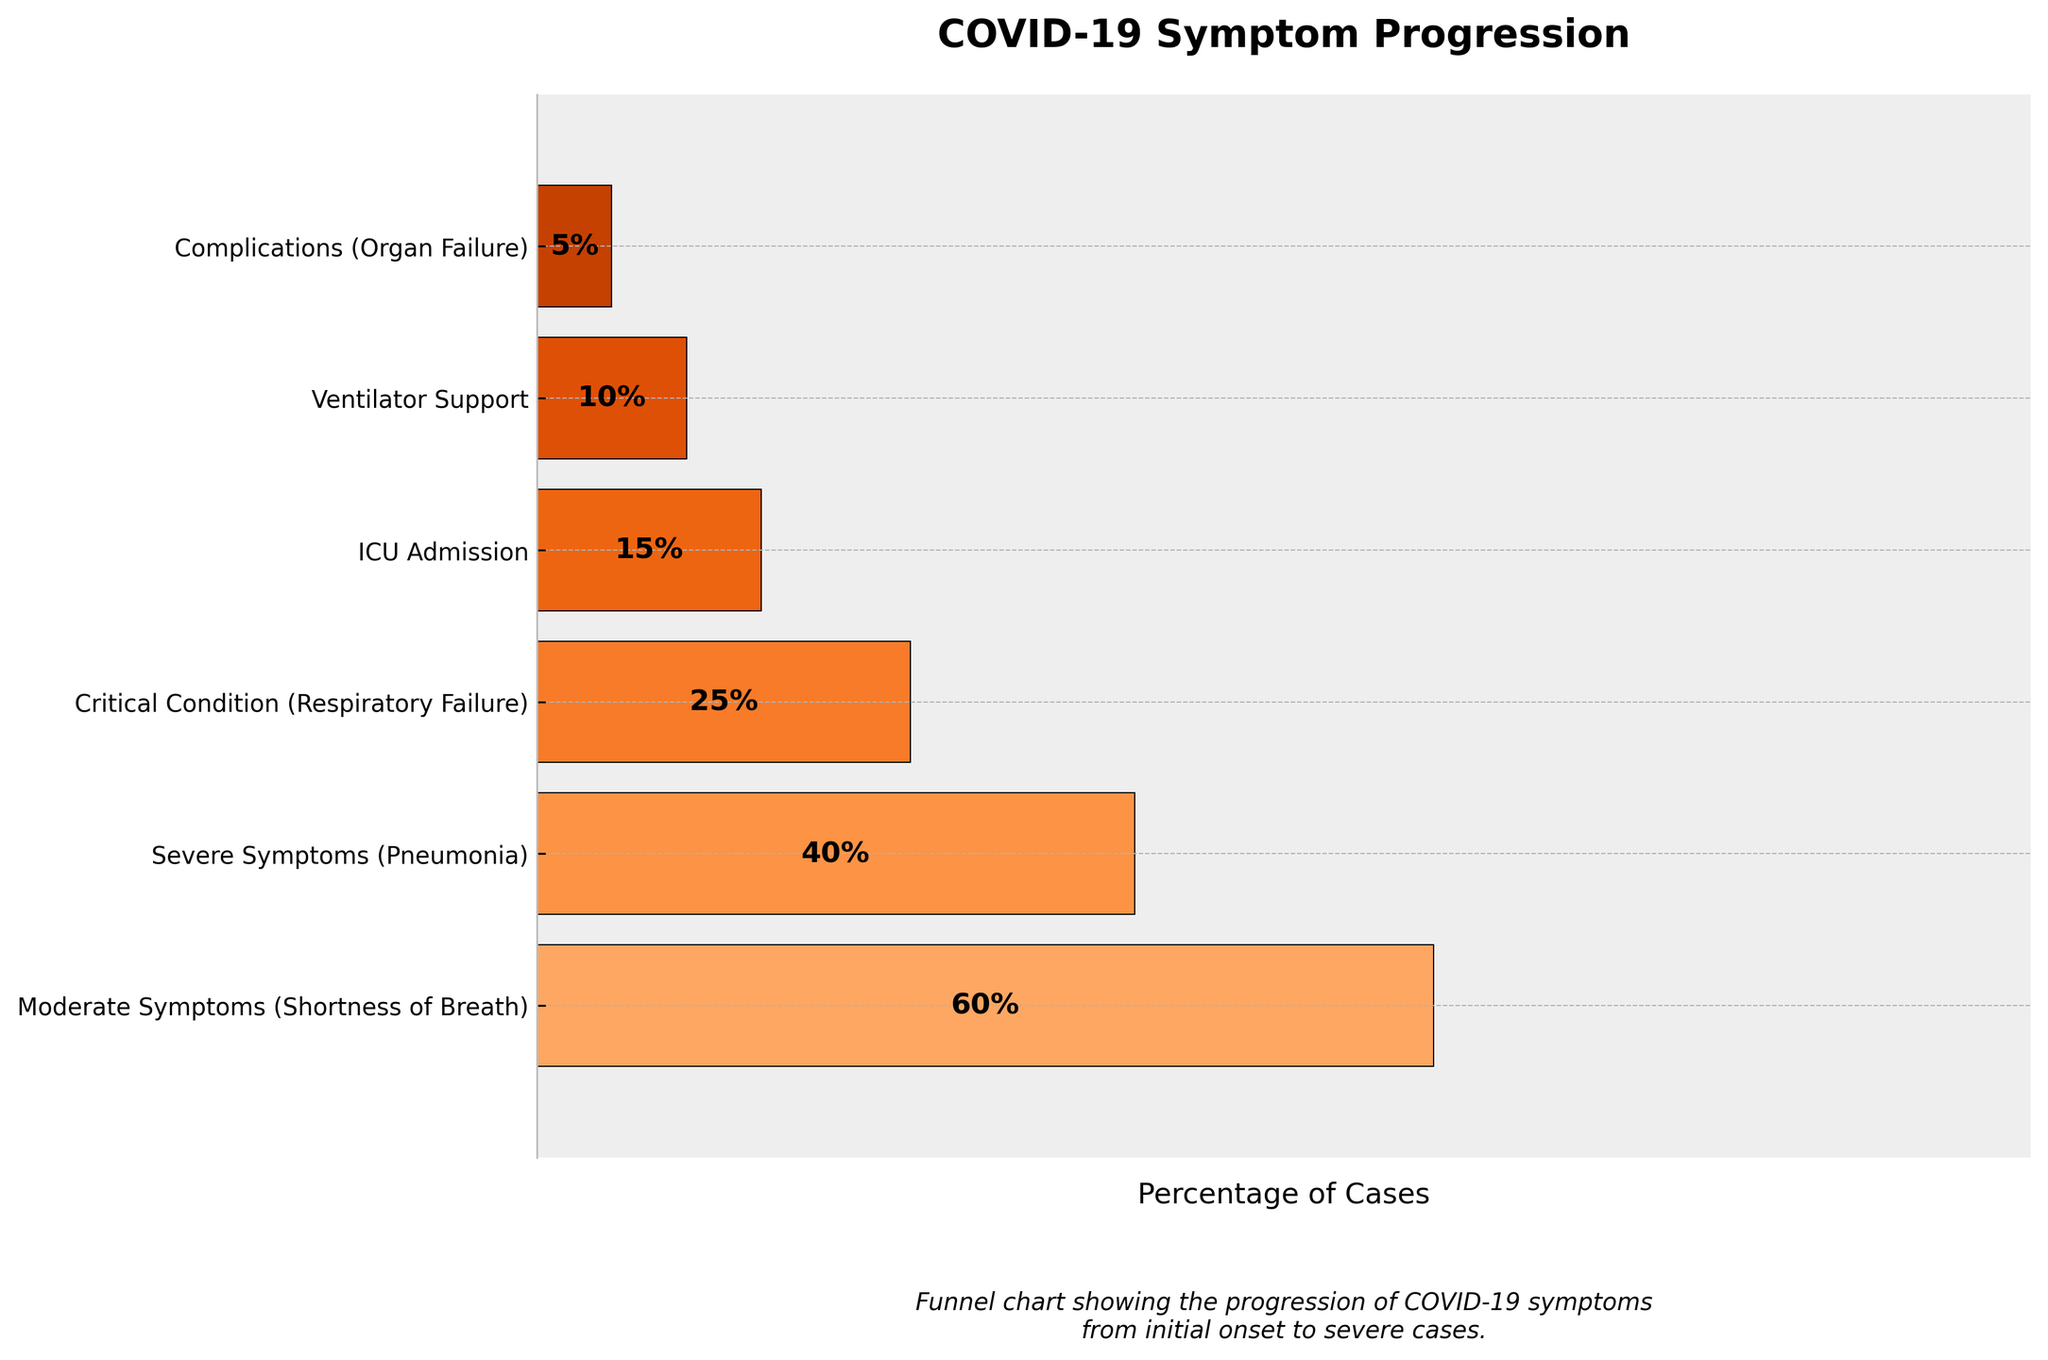What is the title of the chart? The title of the chart is displayed at the top of the figure. It describes the overall content of the chart. The title is "COVID-19 Symptom Progression".
Answer: COVID-19 Symptom Progression Which stage has the highest percentage of cases? To find the stage with the highest percentage, look at the percentages listed next to each stage. The stage with the highest percentage is "Moderate Symptoms (Shortness of Breath)" at 60%.
Answer: Moderate Symptoms (Shortness of Breath) How many stages are shown in the chart? Count the number of unique stages listed from top to bottom on the vertical axis. The chart displays six stages.
Answer: 6 What percentage of cases require ICU Admission? The chart shows the percentage next to each stage. The percentage for "ICU Admission" is 15%.
Answer: 15% What are the percentages for Moderate, Severe, and Critical conditions? Look at the percentages listed next to each of these stages. They are: Moderate Symptoms (60%), Severe Symptoms (40%), and Critical Condition (25%). Sum these percentages: 60 + 40 + 25 = 125.
Answer: 125 Which stage shows the lowest percentage of cases? Compare the percentages for each stage. The lowest percentage is shown for "Complications (Organ Failure)" at 5%.
Answer: Complications (Organ Failure) How does the percentage of cases requiring Ventilator Support compare to those with Complications? The percentage is directly shown next to each stage. Ventilator Support has 10%, whereas Complications have 5%. Ventilator Support has a higher percentage.
Answer: Ventilator Support has a higher percentage What stage comes after Severe Symptoms in terms of increasing severity? Follow the progression of the stages listed from top to bottom. After "Severe Symptoms (Pneumonia)" comes "Critical Condition (Respiratory Failure)".
Answer: Critical Condition (Respiratory Failure) What is the cumulative percentage for all stages? Add the percentages of all stages: 60 + 40 + 25 + 15 + 10 + 5 = 155%.
Answer: 155% 